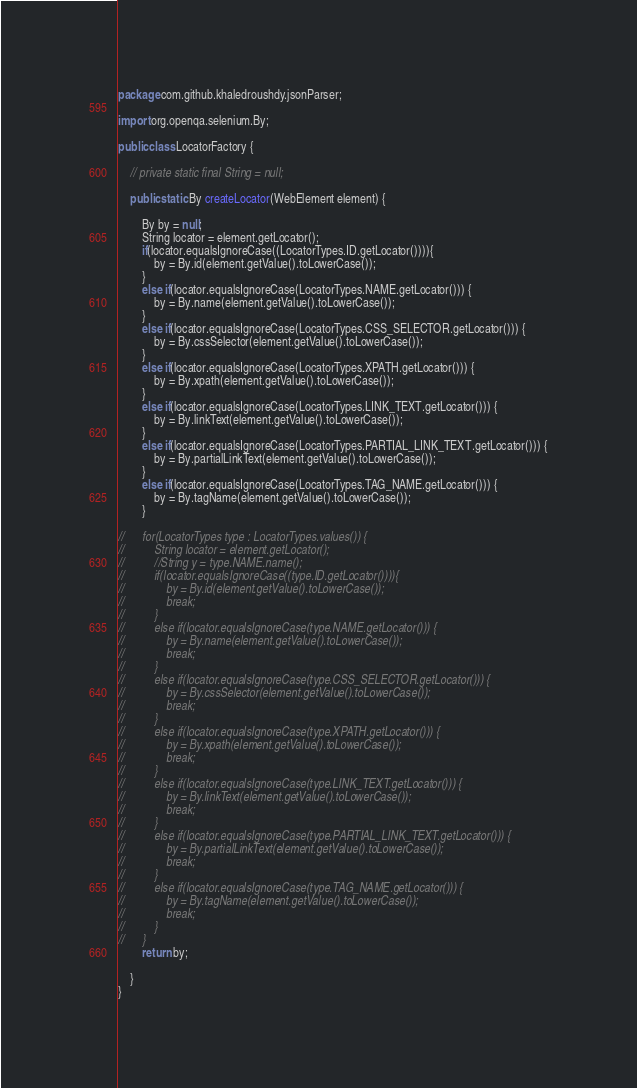<code> <loc_0><loc_0><loc_500><loc_500><_Java_>package com.github.khaledroushdy.jsonParser;

import org.openqa.selenium.By;

public class LocatorFactory {

	// private static final String = null;

	public static By createLocator(WebElement element) {
	
		By by = null;	
		String locator = element.getLocator();
		if(locator.equalsIgnoreCase((LocatorTypes.ID.getLocator()))){
			by = By.id(element.getValue().toLowerCase());
		}
		else if(locator.equalsIgnoreCase(LocatorTypes.NAME.getLocator())) {
			by = By.name(element.getValue().toLowerCase());
		}
		else if(locator.equalsIgnoreCase(LocatorTypes.CSS_SELECTOR.getLocator())) {
			by = By.cssSelector(element.getValue().toLowerCase());
		}
		else if(locator.equalsIgnoreCase(LocatorTypes.XPATH.getLocator())) {
			by = By.xpath(element.getValue().toLowerCase());
		}
		else if(locator.equalsIgnoreCase(LocatorTypes.LINK_TEXT.getLocator())) {
			by = By.linkText(element.getValue().toLowerCase());
		}
		else if(locator.equalsIgnoreCase(LocatorTypes.PARTIAL_LINK_TEXT.getLocator())) {
			by = By.partialLinkText(element.getValue().toLowerCase());
		}
		else if(locator.equalsIgnoreCase(LocatorTypes.TAG_NAME.getLocator())) {
			by = By.tagName(element.getValue().toLowerCase());
		}		
		
//		for(LocatorTypes type : LocatorTypes.values()) {
//			String locator = element.getLocator();
//			//String y = type.NAME.name();
//			if(locator.equalsIgnoreCase((type.ID.getLocator()))){
//				by = By.id(element.getValue().toLowerCase());
//				break;
//			}
//			else if(locator.equalsIgnoreCase(type.NAME.getLocator())) {
//				by = By.name(element.getValue().toLowerCase());
//				break;
//			}
//			else if(locator.equalsIgnoreCase(type.CSS_SELECTOR.getLocator())) {
//				by = By.cssSelector(element.getValue().toLowerCase());
//				break;
//			}
//			else if(locator.equalsIgnoreCase(type.XPATH.getLocator())) {
//				by = By.xpath(element.getValue().toLowerCase());
//				break;
//			}
//			else if(locator.equalsIgnoreCase(type.LINK_TEXT.getLocator())) {
//				by = By.linkText(element.getValue().toLowerCase());
//				break;
//			}
//			else if(locator.equalsIgnoreCase(type.PARTIAL_LINK_TEXT.getLocator())) {
//				by = By.partialLinkText(element.getValue().toLowerCase());
//				break;
//			}
//			else if(locator.equalsIgnoreCase(type.TAG_NAME.getLocator())) {
//				by = By.tagName(element.getValue().toLowerCase());
//				break;
//			}		
//		}
		return by;

	}
}
</code> 